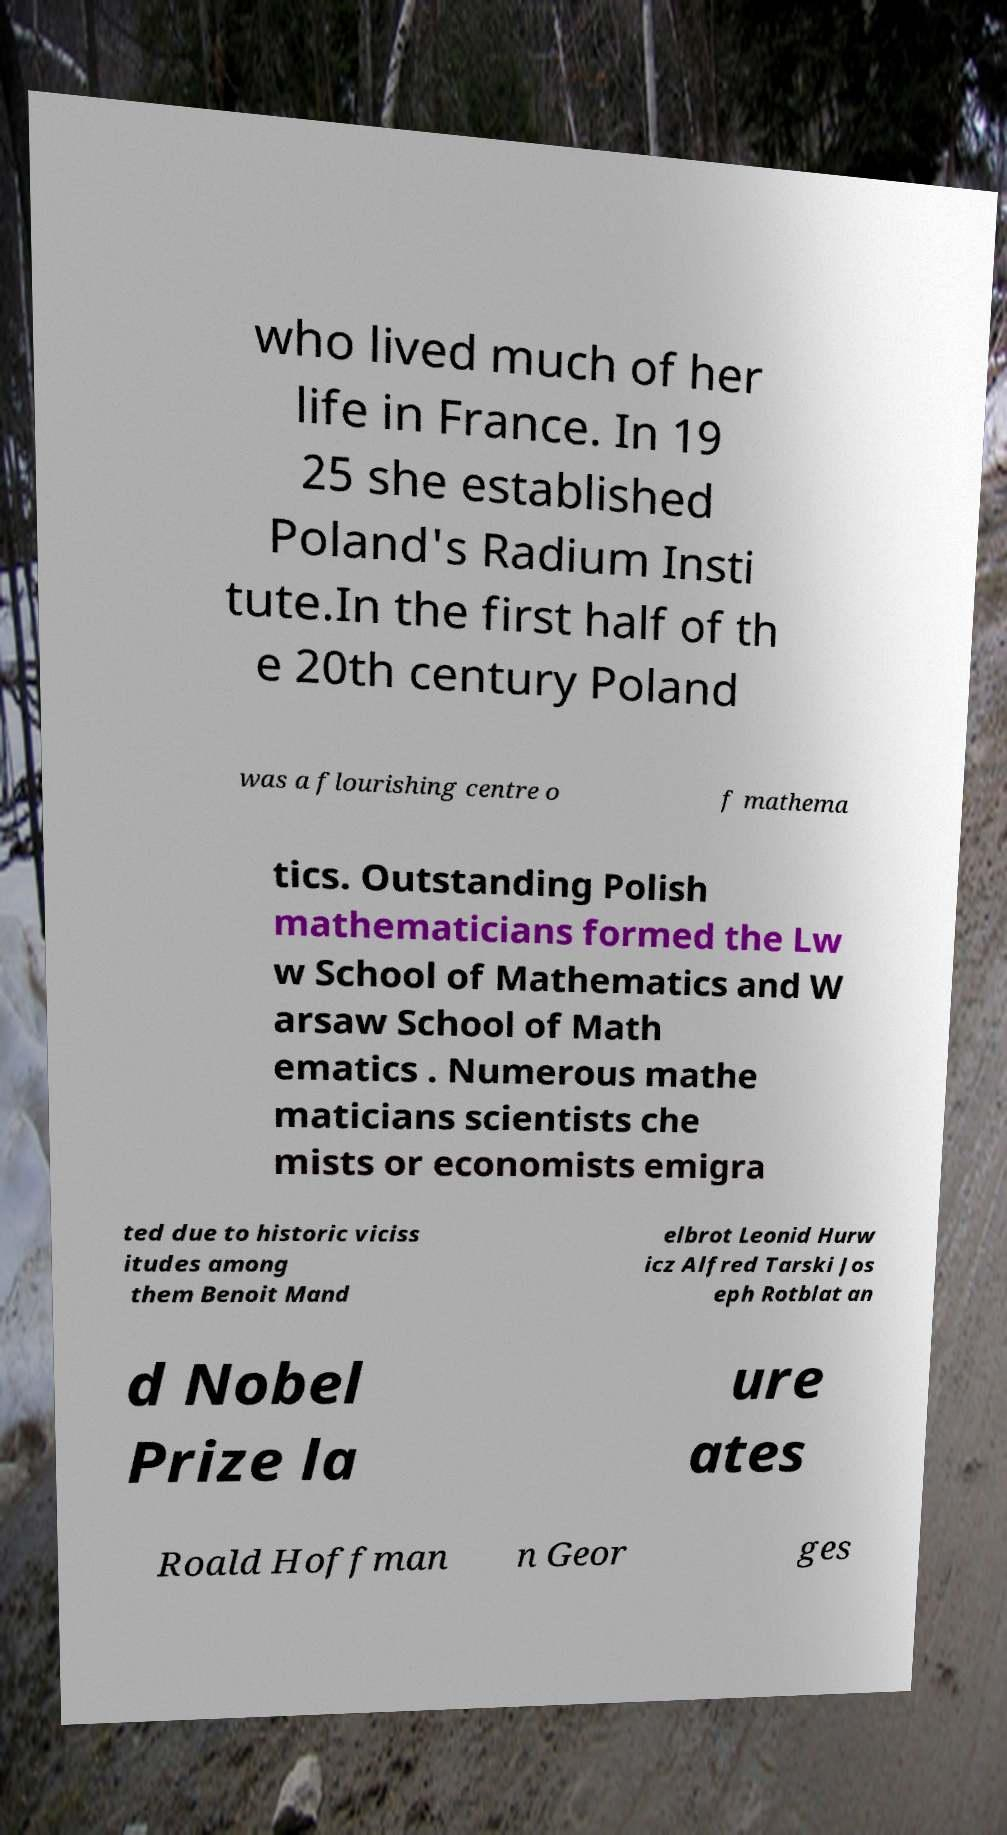Could you assist in decoding the text presented in this image and type it out clearly? who lived much of her life in France. In 19 25 she established Poland's Radium Insti tute.In the first half of th e 20th century Poland was a flourishing centre o f mathema tics. Outstanding Polish mathematicians formed the Lw w School of Mathematics and W arsaw School of Math ematics . Numerous mathe maticians scientists che mists or economists emigra ted due to historic viciss itudes among them Benoit Mand elbrot Leonid Hurw icz Alfred Tarski Jos eph Rotblat an d Nobel Prize la ure ates Roald Hoffman n Geor ges 